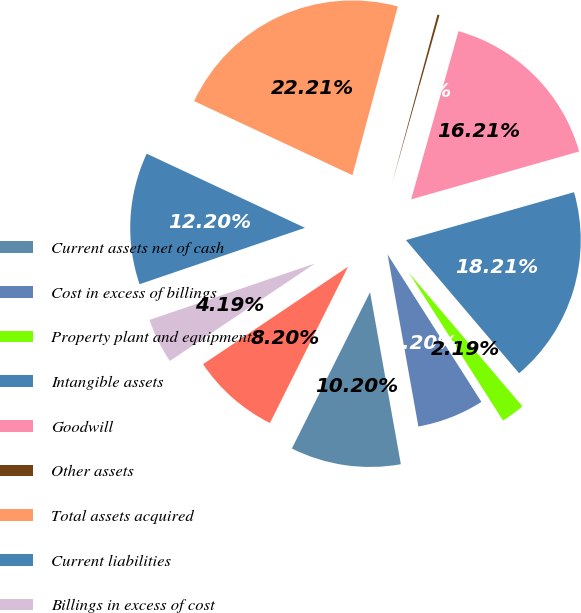<chart> <loc_0><loc_0><loc_500><loc_500><pie_chart><fcel>Current assets net of cash<fcel>Cost in excess of billings<fcel>Property plant and equipment<fcel>Intangible assets<fcel>Goodwill<fcel>Other assets<fcel>Total assets acquired<fcel>Current liabilities<fcel>Billings in excess of cost<fcel>Other liabilities<nl><fcel>10.2%<fcel>6.2%<fcel>2.19%<fcel>18.21%<fcel>16.21%<fcel>0.19%<fcel>22.21%<fcel>12.2%<fcel>4.19%<fcel>8.2%<nl></chart> 